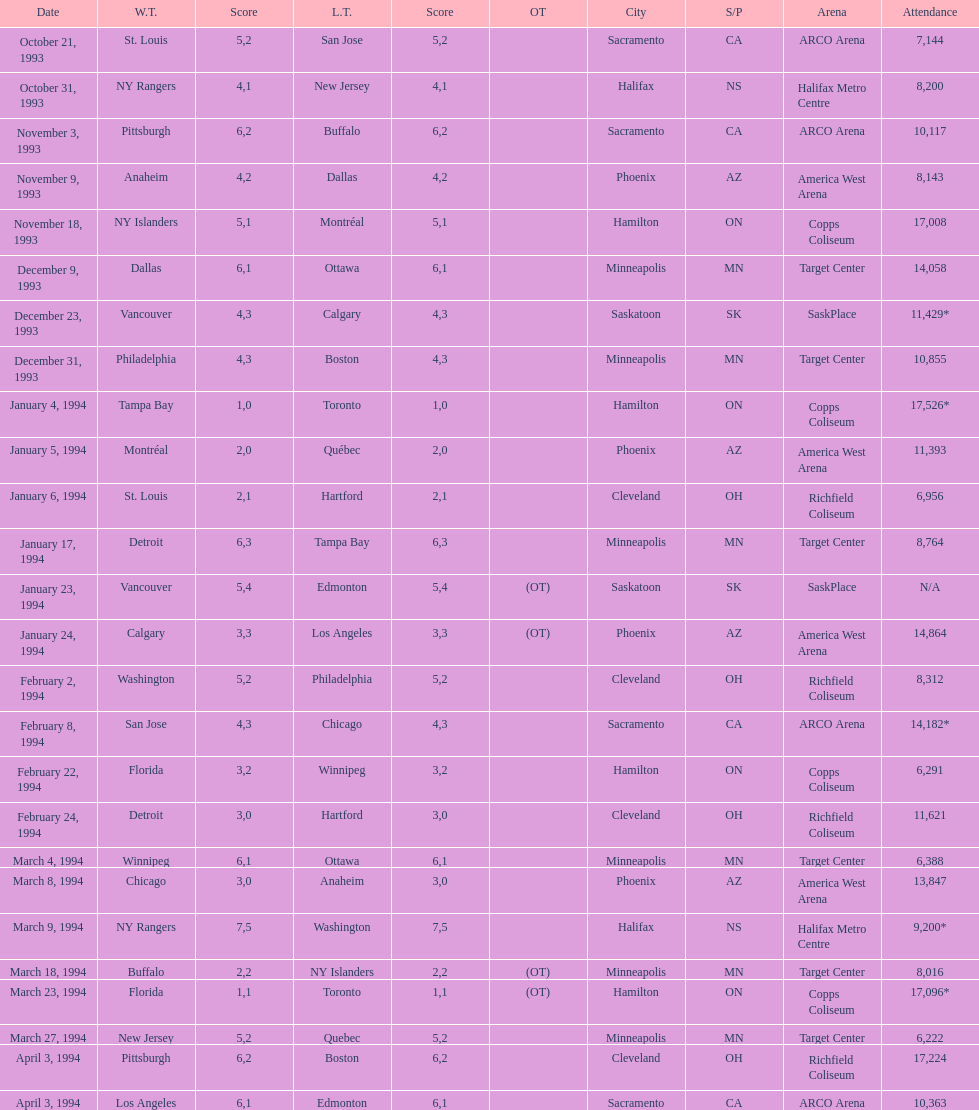How many more people attended the november 18, 1993 games than the november 9th game? 8865. 